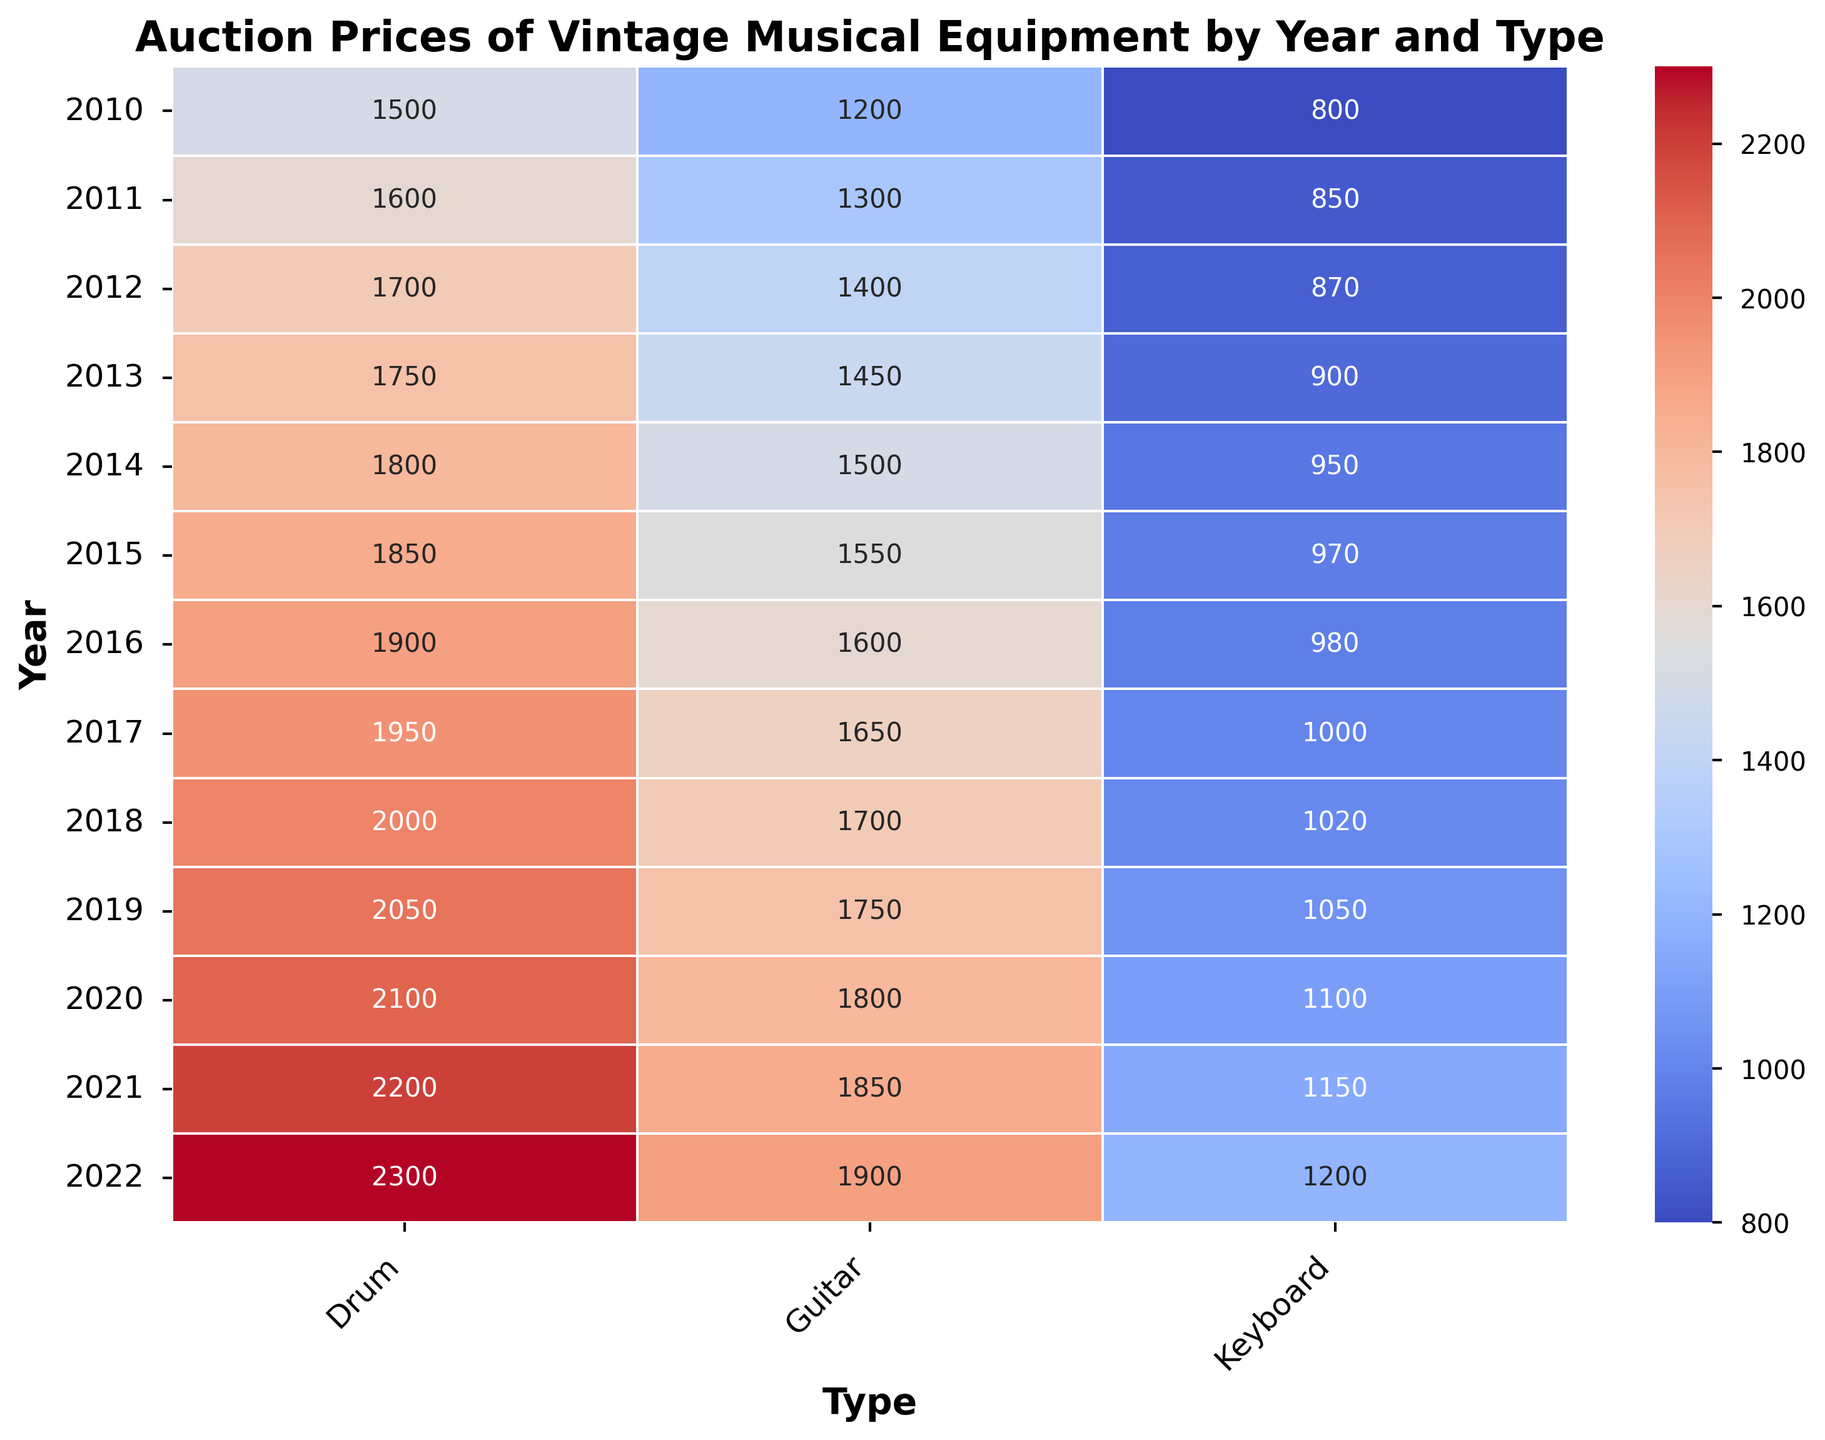What type of musical equipment had the highest average auction price over the years? To find the type with the highest average auction price, we need to calculate the average auction price for each type (Guitar, Keyboard, Drum). Sum all the prices for each type and divide by the number of years (13). Guitars: (1200+1300+1400+1450+1500+1550+1600+1650+1700+1750+1800+1850+1900)/13 = 1607.69. Keyboards: (800+850+870+900+950+970+980+1000+1020+1050+1100+1150+1200)/13 = 987.69. Drums: (1500+1600+1700+1750+1800+1850+1900+1950+2000+2050+2100+2200+2300)/13 = 1861.54. The type with the highest average auction price is the Drum.
Answer: Drum In which year did the Keyboard experience the highest auction price increase compared to the previous year? To identify the year with the highest price increase, calculate the year-to-year differences in prices for Keyboards. Differences: 2010-2011: 50, 2011-2012: 20, 2012-2013: 30, 2013-2014: 50, 2014-2015: 20, 2015-2016: 10, 2016-2017: 20, 2017-2018: 20, 2018-2019: 30, 2019-2020: 50, 2020-2021: 50, 2021-2022: 50. The highest increase is 50, which occurs in years 2010-2011, 2013-2014, 2019-2020, 2020-2021, and 2021-2022.
Answer: 2011, 2014, 2020, 2021, 2022 Between 2011 and 2015, which type of musical equipment had the steadiest increase in auction prices? To determine the steadiest increase, inspect the auction prices of each type from 2011 to 2015 and note the consistency in price changes. Guitars: increases are 100, 100, 50, 50. Keyboards: increases are 50, 20, 30, 50. Drums: increases are 100, 100, 50, 50. The Guitar and Drum both have consistent increases over the years.
Answer: Guitar, Drum Which year showed the highest auction price for Drums within the dataset? Locate the highest value in the Drum column from the heatmap. The values for Drums are consistently increasing yearly. The highest value is in the last year, 2022, with a price of 2300.
Answer: 2022 What is the average auction price for Guitars from 2020 to 2022? Calculate the average auction price by summing the prices from 2020 to 2022 and dividing by the number of years. Prices: (1800+1850+1900). Sum = 5550. Average = 5550/3.
Answer: 1850 